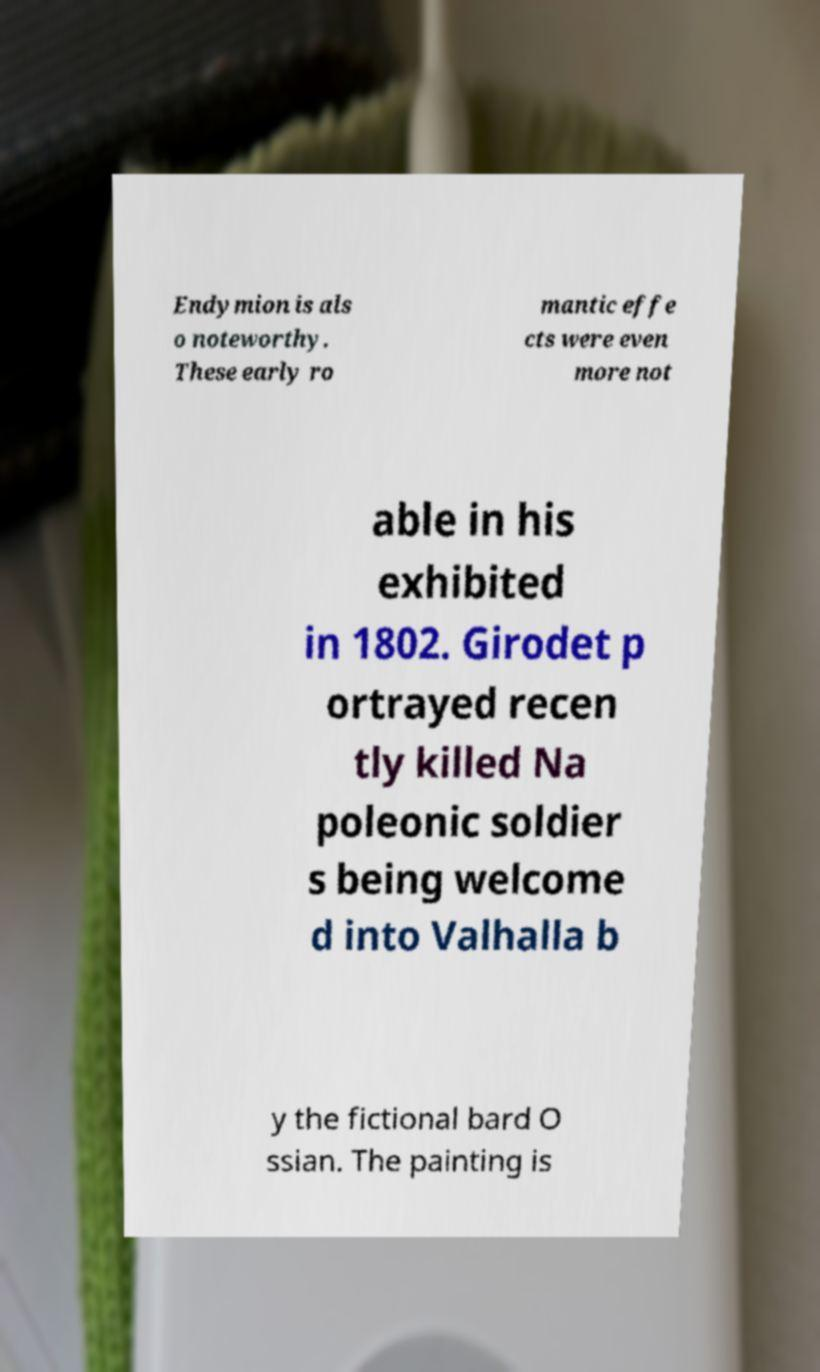Can you read and provide the text displayed in the image?This photo seems to have some interesting text. Can you extract and type it out for me? Endymion is als o noteworthy. These early ro mantic effe cts were even more not able in his exhibited in 1802. Girodet p ortrayed recen tly killed Na poleonic soldier s being welcome d into Valhalla b y the fictional bard O ssian. The painting is 